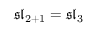Convert formula to latex. <formula><loc_0><loc_0><loc_500><loc_500>{ \mathfrak { s l } } _ { 2 + 1 } = { \mathfrak { s l } } _ { 3 }</formula> 